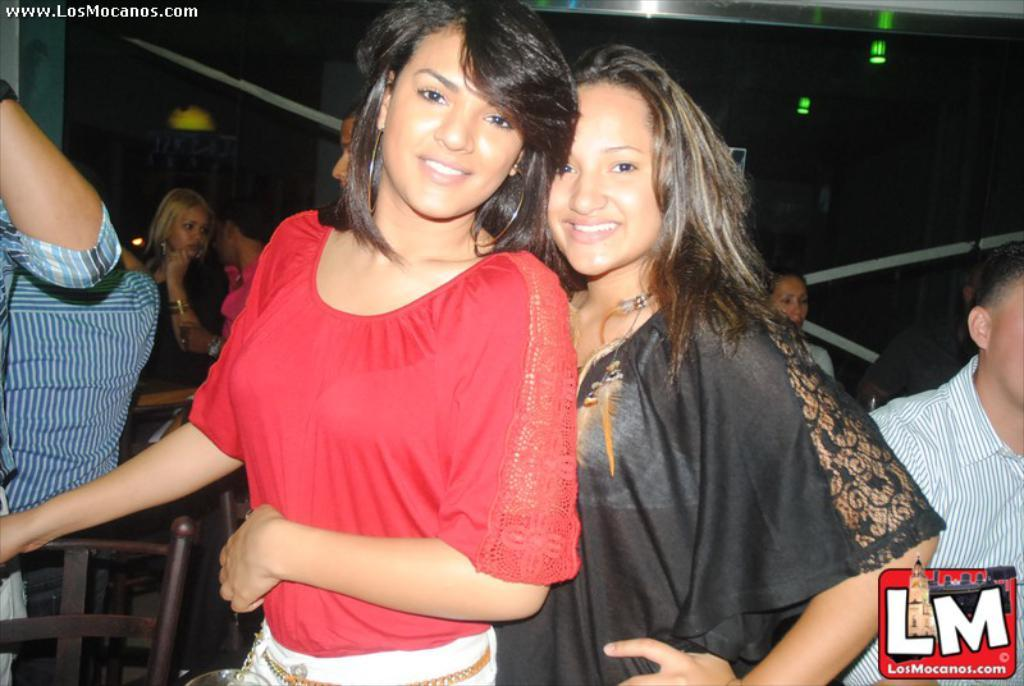How many women are in the image? There are two women in the image. What are the women doing in the image? The women are standing and smiling. Who else is present in the image besides the women? There is a man in the image. Can you describe the background of the image? There are people in the background of the image. What is on the roof in the image? There is a light on the roof in the image. What type of slope can be seen in the image? There is no slope present in the image. What offer is being made by the man in the image? There is no offer being made in the image, as the man is not interacting with anyone or holding any objects that suggest an offer. 